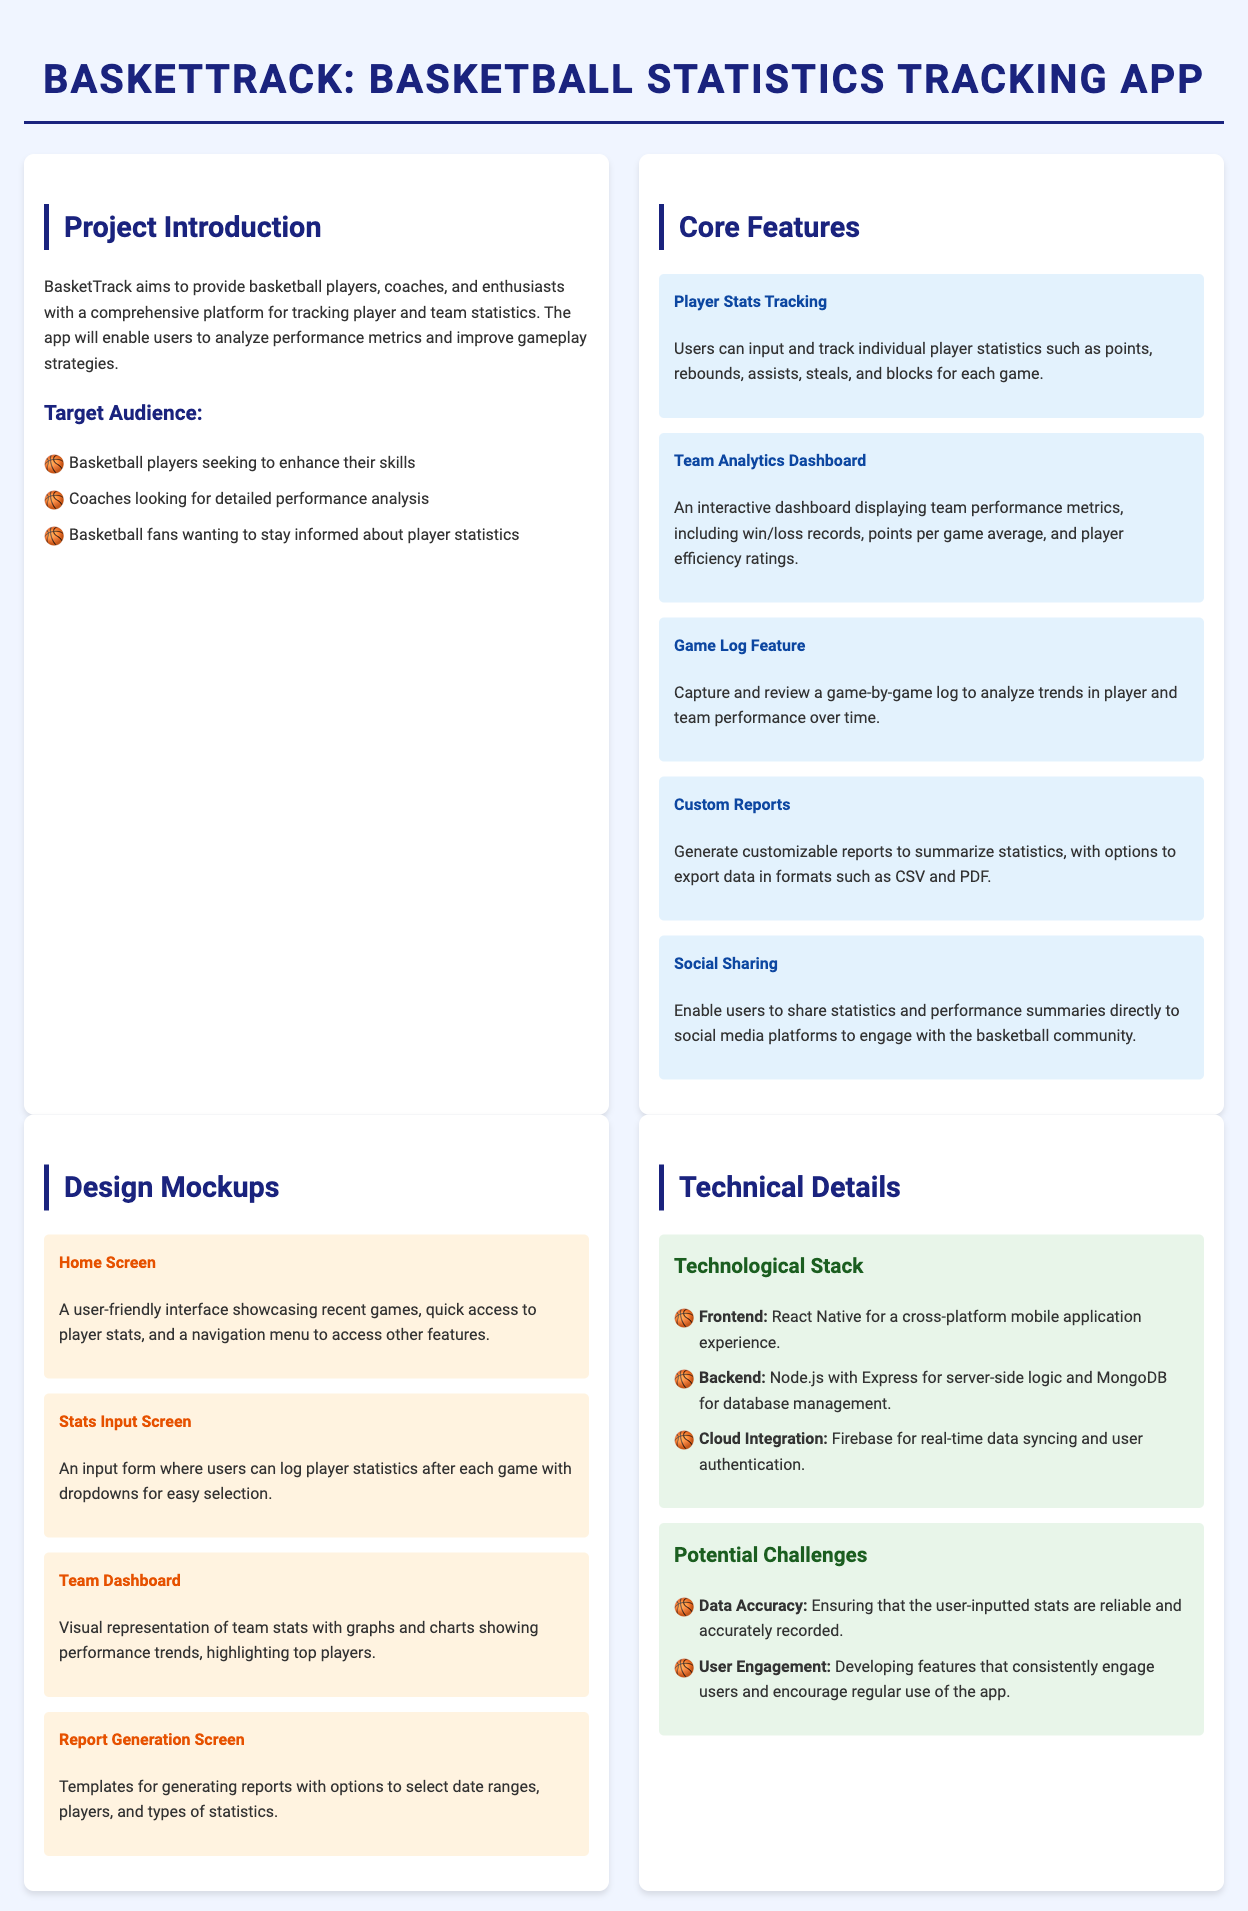What is the title of the project? The title is presented as a heading at the top of the document.
Answer: BasketTrack: Basketball Statistics Tracking App What is the main purpose of the app? The purpose is outlined in the project introduction section of the document.
Answer: To provide a comprehensive platform for tracking player and team statistics Who are the target audiences of the app? The target audience is listed in the project introduction under the section "Target Audience."
Answer: Basketball players, Coaches, Fans What feature allows users to log individual player statistics? This feature is mentioned specifically in the "Core Features" section of the document.
Answer: Player Stats Tracking What technology is used for the frontend of the app? This information is found in the "Technological Stack" section.
Answer: React Native What challenge is associated with user engagement? This challenge is discussed in the "Potential Challenges" section of the document.
Answer: Developing features that consistently engage users How many design mockups are mentioned in the document? The number of mockups can be counted from the "Design Mockups" section.
Answer: Four What type of reports can users generate? The type of reports is specified in the "Custom Reports" feature description.
Answer: Customizable reports What platform will the app utilize for real-time data syncing? This platform is stated in the "Technological Stack" section under cloud integration.
Answer: Firebase 